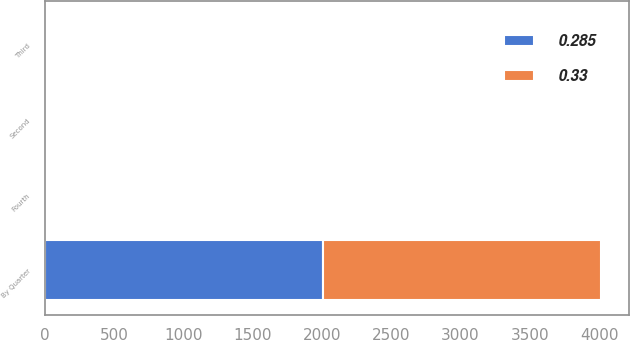Convert chart. <chart><loc_0><loc_0><loc_500><loc_500><stacked_bar_chart><ecel><fcel>By Quarter<fcel>Second<fcel>Third<fcel>Fourth<nl><fcel>0.33<fcel>2009<fcel>0.33<fcel>0.33<fcel>0.33<nl><fcel>0.285<fcel>2008<fcel>0.28<fcel>0.28<fcel>0.28<nl></chart> 